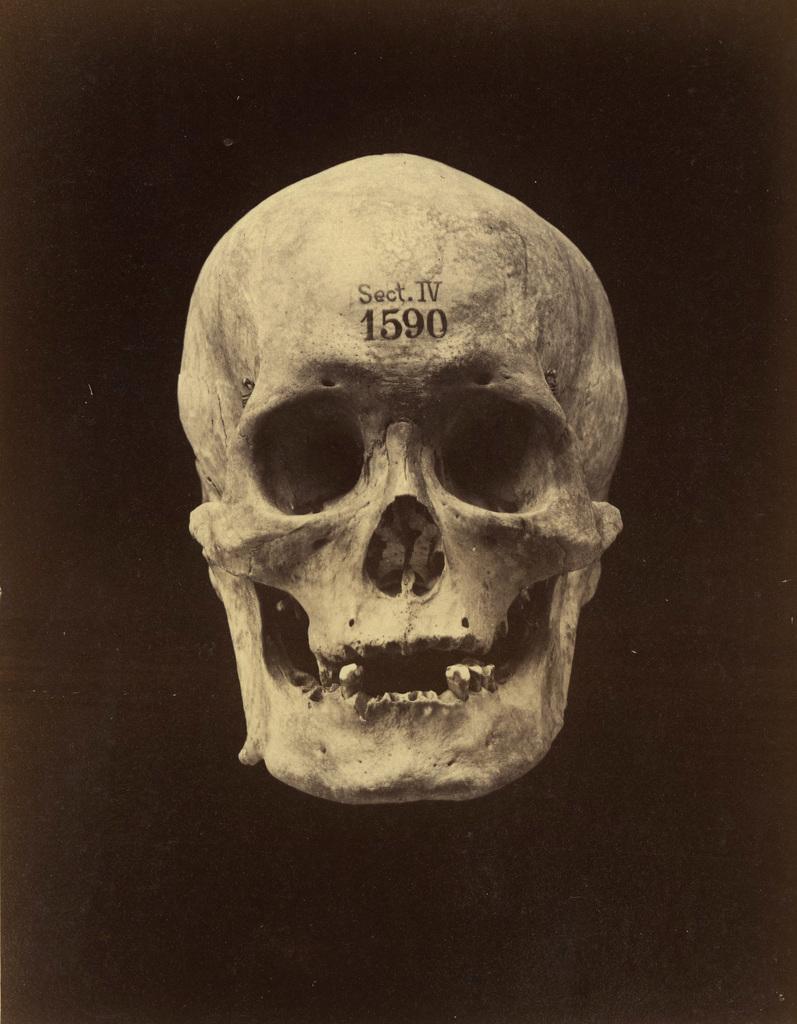Describe this image in one or two sentences. In this image we can see a skull with some text and number on it, the background is dark. 